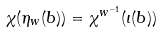<formula> <loc_0><loc_0><loc_500><loc_500>\chi ( \eta _ { w } ( b ) ) = \chi ^ { w ^ { - 1 } } ( \iota ( b ) )</formula> 